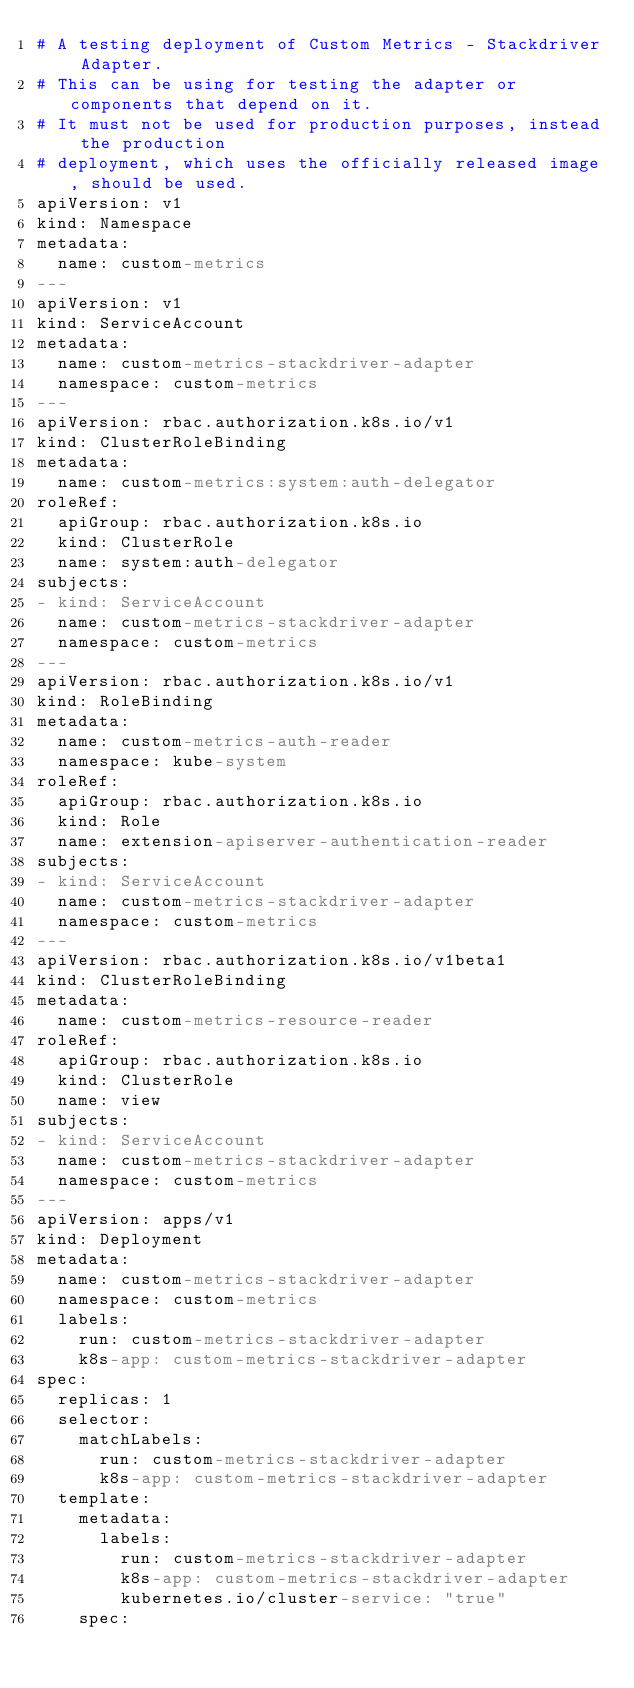<code> <loc_0><loc_0><loc_500><loc_500><_YAML_># A testing deployment of Custom Metrics - Stackdriver Adapter.
# This can be using for testing the adapter or components that depend on it.
# It must not be used for production purposes, instead the production
# deployment, which uses the officially released image, should be used.
apiVersion: v1
kind: Namespace
metadata:
  name: custom-metrics
---
apiVersion: v1
kind: ServiceAccount
metadata:
  name: custom-metrics-stackdriver-adapter
  namespace: custom-metrics
---
apiVersion: rbac.authorization.k8s.io/v1
kind: ClusterRoleBinding
metadata:
  name: custom-metrics:system:auth-delegator
roleRef:
  apiGroup: rbac.authorization.k8s.io
  kind: ClusterRole
  name: system:auth-delegator
subjects:
- kind: ServiceAccount
  name: custom-metrics-stackdriver-adapter
  namespace: custom-metrics
---
apiVersion: rbac.authorization.k8s.io/v1
kind: RoleBinding
metadata:
  name: custom-metrics-auth-reader
  namespace: kube-system
roleRef:
  apiGroup: rbac.authorization.k8s.io
  kind: Role
  name: extension-apiserver-authentication-reader
subjects:
- kind: ServiceAccount
  name: custom-metrics-stackdriver-adapter
  namespace: custom-metrics
---
apiVersion: rbac.authorization.k8s.io/v1beta1
kind: ClusterRoleBinding
metadata:
  name: custom-metrics-resource-reader
roleRef:
  apiGroup: rbac.authorization.k8s.io
  kind: ClusterRole
  name: view
subjects:
- kind: ServiceAccount
  name: custom-metrics-stackdriver-adapter
  namespace: custom-metrics
---
apiVersion: apps/v1
kind: Deployment
metadata:
  name: custom-metrics-stackdriver-adapter
  namespace: custom-metrics
  labels:
    run: custom-metrics-stackdriver-adapter
    k8s-app: custom-metrics-stackdriver-adapter
spec:
  replicas: 1
  selector:
    matchLabels:
      run: custom-metrics-stackdriver-adapter
      k8s-app: custom-metrics-stackdriver-adapter
  template:
    metadata:
      labels:
        run: custom-metrics-stackdriver-adapter
        k8s-app: custom-metrics-stackdriver-adapter
        kubernetes.io/cluster-service: "true"
    spec:</code> 